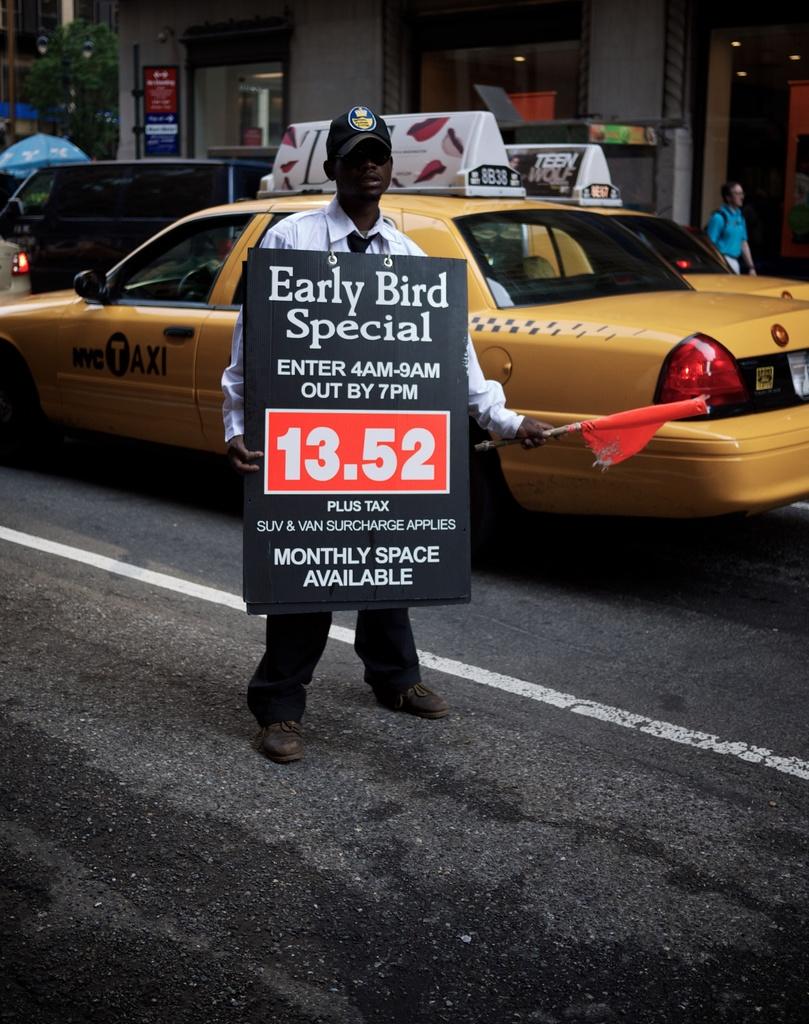What special is this?
Ensure brevity in your answer.  Early bird. What time must you leave?
Offer a very short reply. 7pm. 